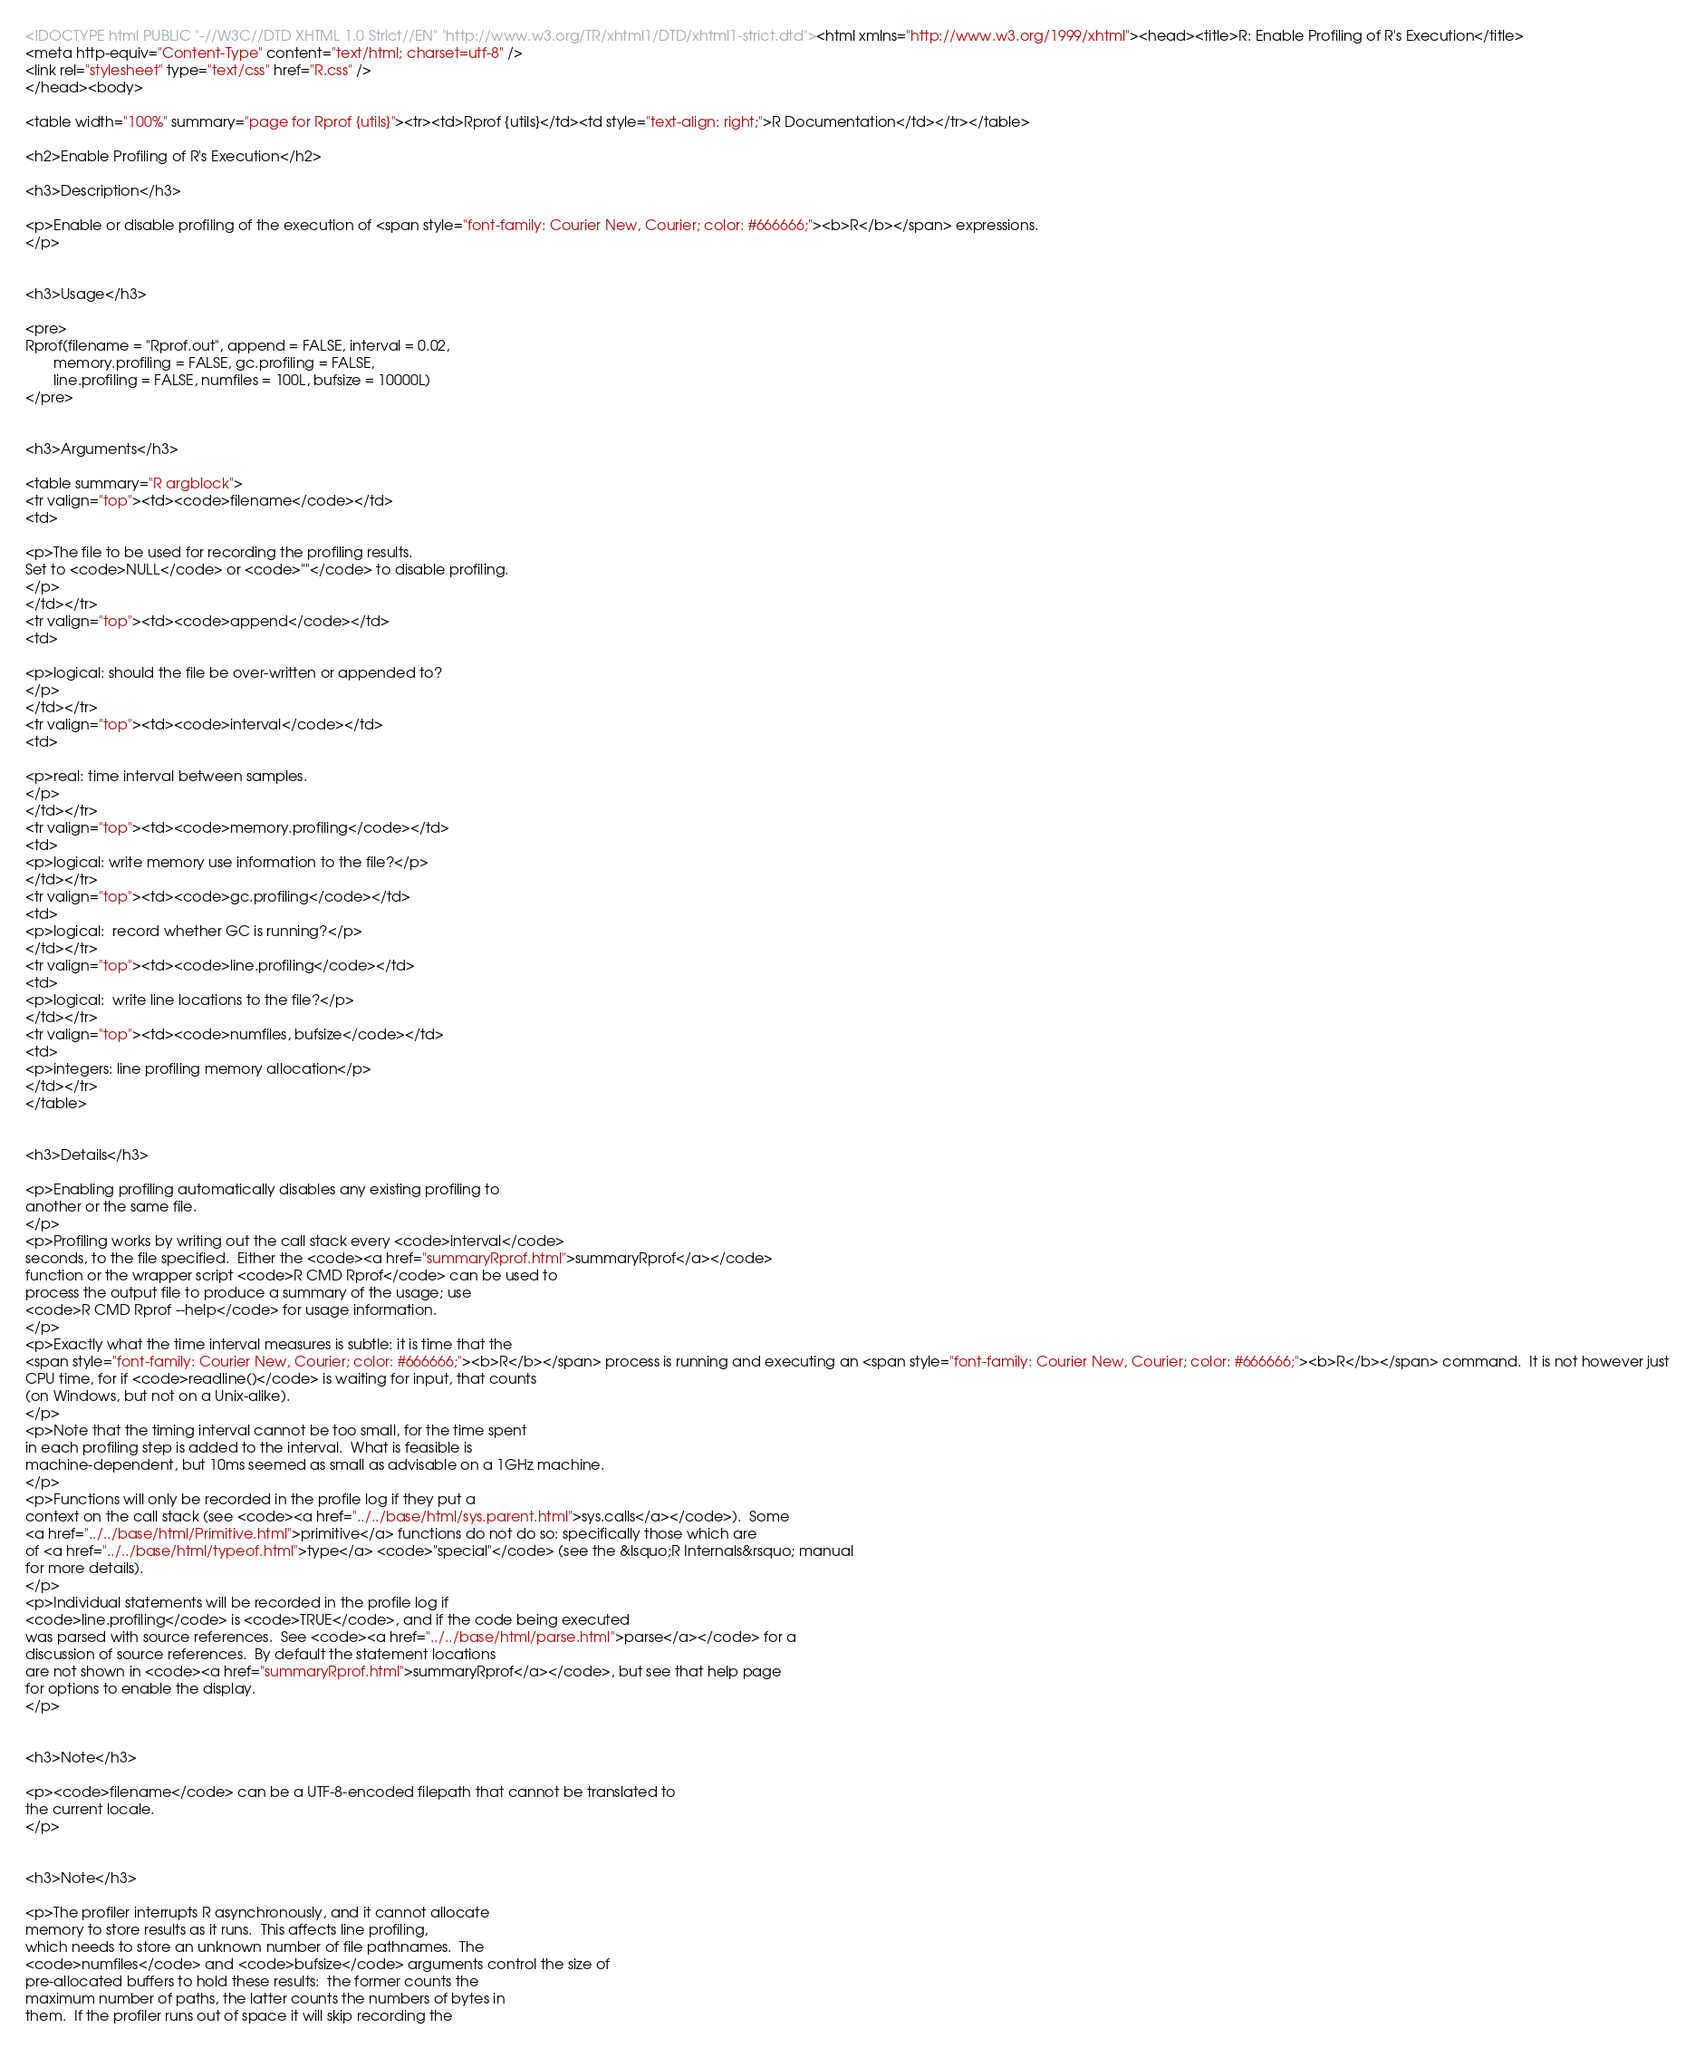Convert code to text. <code><loc_0><loc_0><loc_500><loc_500><_HTML_><!DOCTYPE html PUBLIC "-//W3C//DTD XHTML 1.0 Strict//EN" "http://www.w3.org/TR/xhtml1/DTD/xhtml1-strict.dtd"><html xmlns="http://www.w3.org/1999/xhtml"><head><title>R: Enable Profiling of R's Execution</title>
<meta http-equiv="Content-Type" content="text/html; charset=utf-8" />
<link rel="stylesheet" type="text/css" href="R.css" />
</head><body>

<table width="100%" summary="page for Rprof {utils}"><tr><td>Rprof {utils}</td><td style="text-align: right;">R Documentation</td></tr></table>

<h2>Enable Profiling of R's Execution</h2>

<h3>Description</h3>

<p>Enable or disable profiling of the execution of <span style="font-family: Courier New, Courier; color: #666666;"><b>R</b></span> expressions.
</p>


<h3>Usage</h3>

<pre>
Rprof(filename = "Rprof.out", append = FALSE, interval = 0.02,
       memory.profiling = FALSE, gc.profiling = FALSE, 
       line.profiling = FALSE, numfiles = 100L, bufsize = 10000L)
</pre>


<h3>Arguments</h3>

<table summary="R argblock">
<tr valign="top"><td><code>filename</code></td>
<td>

<p>The file to be used for recording the profiling results.
Set to <code>NULL</code> or <code>""</code> to disable profiling.
</p>
</td></tr>
<tr valign="top"><td><code>append</code></td>
<td>

<p>logical: should the file be over-written or appended to?
</p>
</td></tr>
<tr valign="top"><td><code>interval</code></td>
<td>

<p>real: time interval between samples.
</p>
</td></tr>
<tr valign="top"><td><code>memory.profiling</code></td>
<td>
<p>logical: write memory use information to the file?</p>
</td></tr>
<tr valign="top"><td><code>gc.profiling</code></td>
<td>
<p>logical:  record whether GC is running?</p>
</td></tr>
<tr valign="top"><td><code>line.profiling</code></td>
<td>
<p>logical:  write line locations to the file?</p>
</td></tr>
<tr valign="top"><td><code>numfiles, bufsize</code></td>
<td>
<p>integers: line profiling memory allocation</p>
</td></tr>
</table>


<h3>Details</h3>

<p>Enabling profiling automatically disables any existing profiling to
another or the same file.
</p>
<p>Profiling works by writing out the call stack every <code>interval</code>
seconds, to the file specified.  Either the <code><a href="summaryRprof.html">summaryRprof</a></code>
function or the wrapper script <code>R CMD Rprof</code> can be used to
process the output file to produce a summary of the usage; use
<code>R CMD Rprof --help</code> for usage information.
</p>
<p>Exactly what the time interval measures is subtle: it is time that the
<span style="font-family: Courier New, Courier; color: #666666;"><b>R</b></span> process is running and executing an <span style="font-family: Courier New, Courier; color: #666666;"><b>R</b></span> command.  It is not however just
CPU time, for if <code>readline()</code> is waiting for input, that counts
(on Windows, but not on a Unix-alike).
</p>
<p>Note that the timing interval cannot be too small, for the time spent
in each profiling step is added to the interval.  What is feasible is
machine-dependent, but 10ms seemed as small as advisable on a 1GHz machine.
</p>
<p>Functions will only be recorded in the profile log if they put a
context on the call stack (see <code><a href="../../base/html/sys.parent.html">sys.calls</a></code>).  Some
<a href="../../base/html/Primitive.html">primitive</a> functions do not do so: specifically those which are
of <a href="../../base/html/typeof.html">type</a> <code>"special"</code> (see the &lsquo;R Internals&rsquo; manual
for more details).
</p>
<p>Individual statements will be recorded in the profile log if
<code>line.profiling</code> is <code>TRUE</code>, and if the code being executed
was parsed with source references.  See <code><a href="../../base/html/parse.html">parse</a></code> for a
discussion of source references.  By default the statement locations
are not shown in <code><a href="summaryRprof.html">summaryRprof</a></code>, but see that help page
for options to enable the display.    
</p>


<h3>Note</h3>

<p><code>filename</code> can be a UTF-8-encoded filepath that cannot be translated to
the current locale.
</p>


<h3>Note</h3>

<p>The profiler interrupts R asynchronously, and it cannot allocate
memory to store results as it runs.  This affects line profiling,
which needs to store an unknown number of file pathnames.  The
<code>numfiles</code> and <code>bufsize</code> arguments control the size of 
pre-allocated buffers to hold these results:  the former counts the
maximum number of paths, the latter counts the numbers of bytes in
them.  If the profiler runs out of space it will skip recording the</code> 